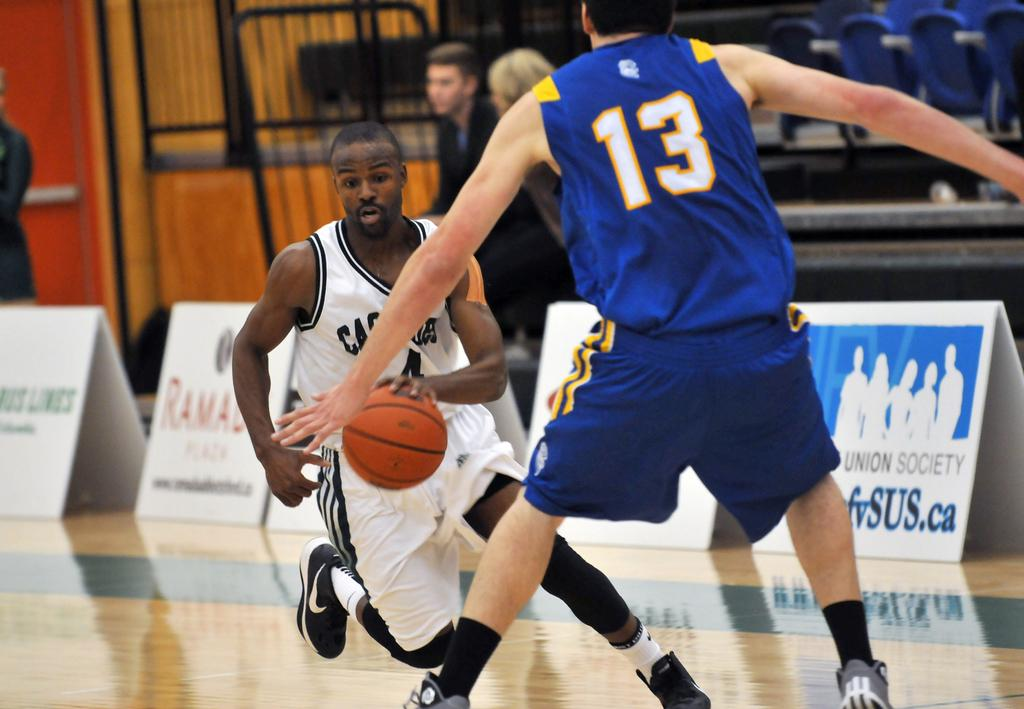<image>
Give a short and clear explanation of the subsequent image. Player number 13 in the blue jersey is trying to block the player in the white uniform. 